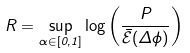<formula> <loc_0><loc_0><loc_500><loc_500>R = \sup _ { \alpha \in [ 0 , 1 ] } \log \left ( \frac { P } { \mathcal { \bar { E } } ( \Delta \phi ) } \right )</formula> 